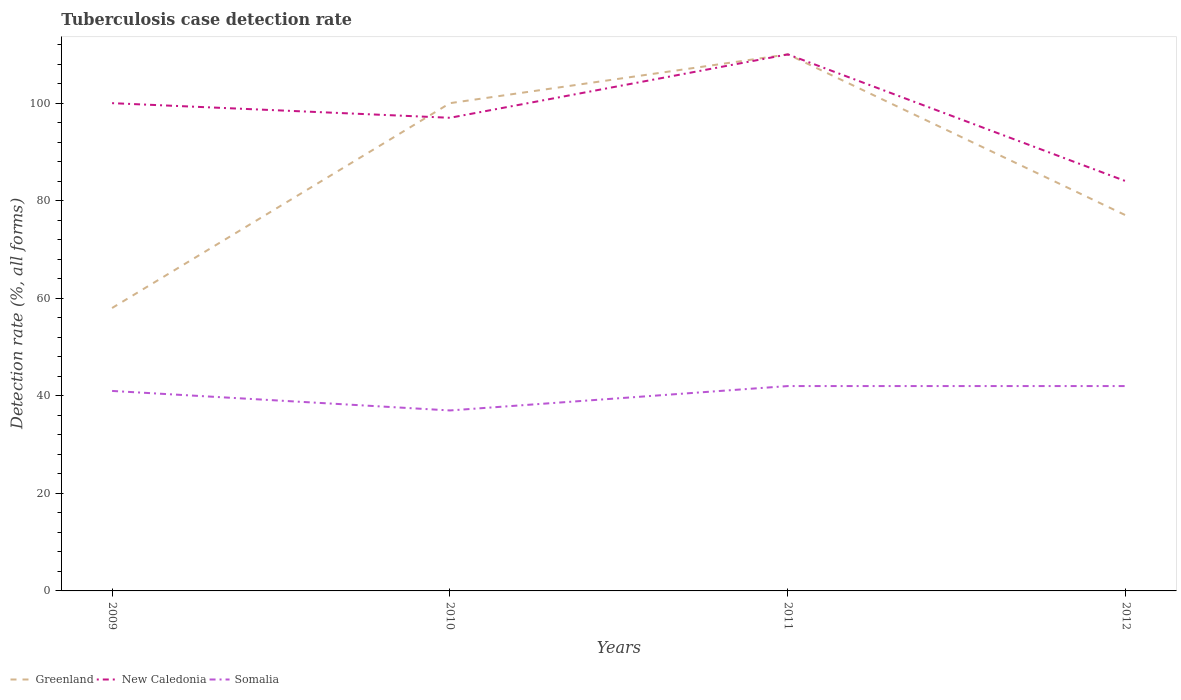Does the line corresponding to New Caledonia intersect with the line corresponding to Greenland?
Keep it short and to the point. Yes. Is the number of lines equal to the number of legend labels?
Your answer should be very brief. Yes. Across all years, what is the maximum tuberculosis case detection rate in in New Caledonia?
Your answer should be very brief. 84. What is the difference between the highest and the second highest tuberculosis case detection rate in in Somalia?
Give a very brief answer. 5. What is the difference between the highest and the lowest tuberculosis case detection rate in in New Caledonia?
Keep it short and to the point. 2. How many lines are there?
Give a very brief answer. 3. What is the difference between two consecutive major ticks on the Y-axis?
Keep it short and to the point. 20. Does the graph contain any zero values?
Your answer should be very brief. No. Does the graph contain grids?
Offer a very short reply. No. How many legend labels are there?
Your answer should be very brief. 3. What is the title of the graph?
Ensure brevity in your answer.  Tuberculosis case detection rate. What is the label or title of the X-axis?
Your answer should be compact. Years. What is the label or title of the Y-axis?
Your answer should be compact. Detection rate (%, all forms). What is the Detection rate (%, all forms) of Somalia in 2009?
Make the answer very short. 41. What is the Detection rate (%, all forms) in Greenland in 2010?
Give a very brief answer. 100. What is the Detection rate (%, all forms) of New Caledonia in 2010?
Provide a short and direct response. 97. What is the Detection rate (%, all forms) in Greenland in 2011?
Provide a short and direct response. 110. What is the Detection rate (%, all forms) of New Caledonia in 2011?
Provide a short and direct response. 110. What is the Detection rate (%, all forms) in Somalia in 2011?
Your answer should be very brief. 42. What is the Detection rate (%, all forms) in New Caledonia in 2012?
Provide a succinct answer. 84. What is the Detection rate (%, all forms) in Somalia in 2012?
Keep it short and to the point. 42. Across all years, what is the maximum Detection rate (%, all forms) in Greenland?
Provide a short and direct response. 110. Across all years, what is the maximum Detection rate (%, all forms) in New Caledonia?
Provide a succinct answer. 110. Across all years, what is the minimum Detection rate (%, all forms) of Greenland?
Provide a succinct answer. 58. Across all years, what is the minimum Detection rate (%, all forms) in New Caledonia?
Give a very brief answer. 84. What is the total Detection rate (%, all forms) in Greenland in the graph?
Your answer should be very brief. 345. What is the total Detection rate (%, all forms) of New Caledonia in the graph?
Ensure brevity in your answer.  391. What is the total Detection rate (%, all forms) in Somalia in the graph?
Keep it short and to the point. 162. What is the difference between the Detection rate (%, all forms) in Greenland in 2009 and that in 2010?
Your answer should be compact. -42. What is the difference between the Detection rate (%, all forms) of Greenland in 2009 and that in 2011?
Provide a succinct answer. -52. What is the difference between the Detection rate (%, all forms) in Somalia in 2009 and that in 2011?
Your answer should be very brief. -1. What is the difference between the Detection rate (%, all forms) in Greenland in 2009 and that in 2012?
Your answer should be very brief. -19. What is the difference between the Detection rate (%, all forms) of New Caledonia in 2009 and that in 2012?
Your answer should be very brief. 16. What is the difference between the Detection rate (%, all forms) in Greenland in 2010 and that in 2011?
Offer a very short reply. -10. What is the difference between the Detection rate (%, all forms) of Somalia in 2010 and that in 2011?
Offer a terse response. -5. What is the difference between the Detection rate (%, all forms) in Somalia in 2010 and that in 2012?
Provide a short and direct response. -5. What is the difference between the Detection rate (%, all forms) in New Caledonia in 2011 and that in 2012?
Ensure brevity in your answer.  26. What is the difference between the Detection rate (%, all forms) of Somalia in 2011 and that in 2012?
Your answer should be very brief. 0. What is the difference between the Detection rate (%, all forms) in Greenland in 2009 and the Detection rate (%, all forms) in New Caledonia in 2010?
Keep it short and to the point. -39. What is the difference between the Detection rate (%, all forms) of Greenland in 2009 and the Detection rate (%, all forms) of Somalia in 2010?
Provide a short and direct response. 21. What is the difference between the Detection rate (%, all forms) of Greenland in 2009 and the Detection rate (%, all forms) of New Caledonia in 2011?
Offer a very short reply. -52. What is the difference between the Detection rate (%, all forms) of Greenland in 2009 and the Detection rate (%, all forms) of Somalia in 2011?
Keep it short and to the point. 16. What is the difference between the Detection rate (%, all forms) of New Caledonia in 2009 and the Detection rate (%, all forms) of Somalia in 2011?
Keep it short and to the point. 58. What is the difference between the Detection rate (%, all forms) in Greenland in 2009 and the Detection rate (%, all forms) in New Caledonia in 2012?
Keep it short and to the point. -26. What is the difference between the Detection rate (%, all forms) in Greenland in 2009 and the Detection rate (%, all forms) in Somalia in 2012?
Your answer should be very brief. 16. What is the difference between the Detection rate (%, all forms) in Greenland in 2010 and the Detection rate (%, all forms) in New Caledonia in 2011?
Provide a short and direct response. -10. What is the difference between the Detection rate (%, all forms) of New Caledonia in 2010 and the Detection rate (%, all forms) of Somalia in 2011?
Give a very brief answer. 55. What is the difference between the Detection rate (%, all forms) of New Caledonia in 2010 and the Detection rate (%, all forms) of Somalia in 2012?
Your answer should be compact. 55. What is the average Detection rate (%, all forms) of Greenland per year?
Your response must be concise. 86.25. What is the average Detection rate (%, all forms) in New Caledonia per year?
Offer a very short reply. 97.75. What is the average Detection rate (%, all forms) of Somalia per year?
Give a very brief answer. 40.5. In the year 2009, what is the difference between the Detection rate (%, all forms) of Greenland and Detection rate (%, all forms) of New Caledonia?
Your answer should be very brief. -42. In the year 2009, what is the difference between the Detection rate (%, all forms) in New Caledonia and Detection rate (%, all forms) in Somalia?
Give a very brief answer. 59. In the year 2010, what is the difference between the Detection rate (%, all forms) in New Caledonia and Detection rate (%, all forms) in Somalia?
Provide a short and direct response. 60. In the year 2011, what is the difference between the Detection rate (%, all forms) of Greenland and Detection rate (%, all forms) of Somalia?
Your answer should be compact. 68. In the year 2012, what is the difference between the Detection rate (%, all forms) in New Caledonia and Detection rate (%, all forms) in Somalia?
Offer a terse response. 42. What is the ratio of the Detection rate (%, all forms) in Greenland in 2009 to that in 2010?
Ensure brevity in your answer.  0.58. What is the ratio of the Detection rate (%, all forms) of New Caledonia in 2009 to that in 2010?
Ensure brevity in your answer.  1.03. What is the ratio of the Detection rate (%, all forms) in Somalia in 2009 to that in 2010?
Your response must be concise. 1.11. What is the ratio of the Detection rate (%, all forms) in Greenland in 2009 to that in 2011?
Provide a succinct answer. 0.53. What is the ratio of the Detection rate (%, all forms) of New Caledonia in 2009 to that in 2011?
Ensure brevity in your answer.  0.91. What is the ratio of the Detection rate (%, all forms) of Somalia in 2009 to that in 2011?
Provide a succinct answer. 0.98. What is the ratio of the Detection rate (%, all forms) of Greenland in 2009 to that in 2012?
Make the answer very short. 0.75. What is the ratio of the Detection rate (%, all forms) of New Caledonia in 2009 to that in 2012?
Provide a succinct answer. 1.19. What is the ratio of the Detection rate (%, all forms) of Somalia in 2009 to that in 2012?
Offer a very short reply. 0.98. What is the ratio of the Detection rate (%, all forms) of Greenland in 2010 to that in 2011?
Provide a succinct answer. 0.91. What is the ratio of the Detection rate (%, all forms) of New Caledonia in 2010 to that in 2011?
Ensure brevity in your answer.  0.88. What is the ratio of the Detection rate (%, all forms) in Somalia in 2010 to that in 2011?
Provide a short and direct response. 0.88. What is the ratio of the Detection rate (%, all forms) in Greenland in 2010 to that in 2012?
Ensure brevity in your answer.  1.3. What is the ratio of the Detection rate (%, all forms) in New Caledonia in 2010 to that in 2012?
Offer a terse response. 1.15. What is the ratio of the Detection rate (%, all forms) of Somalia in 2010 to that in 2012?
Your answer should be compact. 0.88. What is the ratio of the Detection rate (%, all forms) in Greenland in 2011 to that in 2012?
Your response must be concise. 1.43. What is the ratio of the Detection rate (%, all forms) in New Caledonia in 2011 to that in 2012?
Offer a terse response. 1.31. What is the ratio of the Detection rate (%, all forms) of Somalia in 2011 to that in 2012?
Provide a short and direct response. 1. What is the difference between the highest and the second highest Detection rate (%, all forms) of Greenland?
Offer a terse response. 10. What is the difference between the highest and the lowest Detection rate (%, all forms) in New Caledonia?
Your response must be concise. 26. 